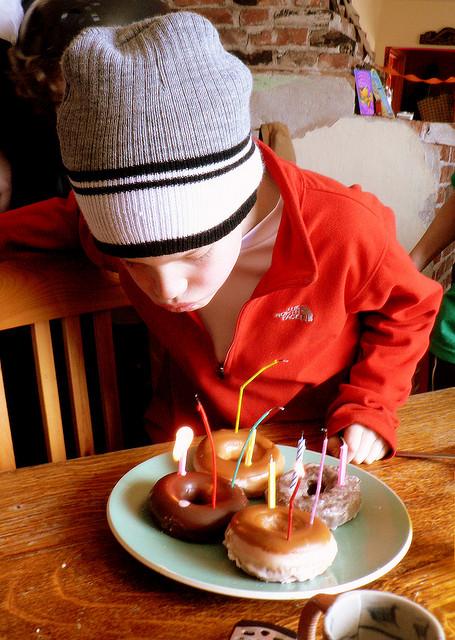How many doughnuts are in the photo?
Be succinct. 4. Is this a club sandwich?
Short answer required. No. Is he celebrating his birthday?
Short answer required. Yes. What color is his shirt?
Give a very brief answer. White. 